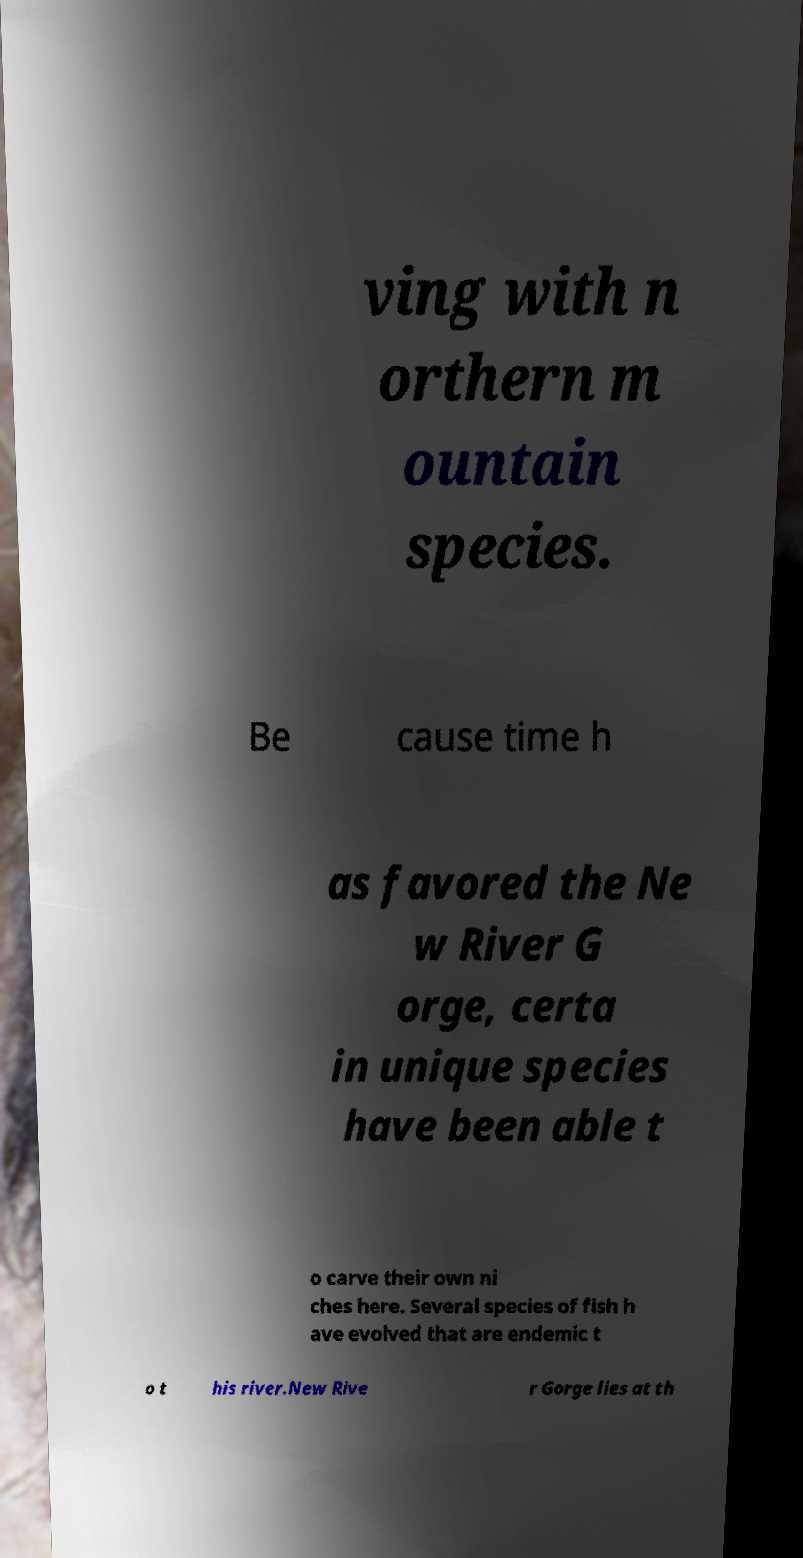There's text embedded in this image that I need extracted. Can you transcribe it verbatim? ving with n orthern m ountain species. Be cause time h as favored the Ne w River G orge, certa in unique species have been able t o carve their own ni ches here. Several species of fish h ave evolved that are endemic t o t his river.New Rive r Gorge lies at th 